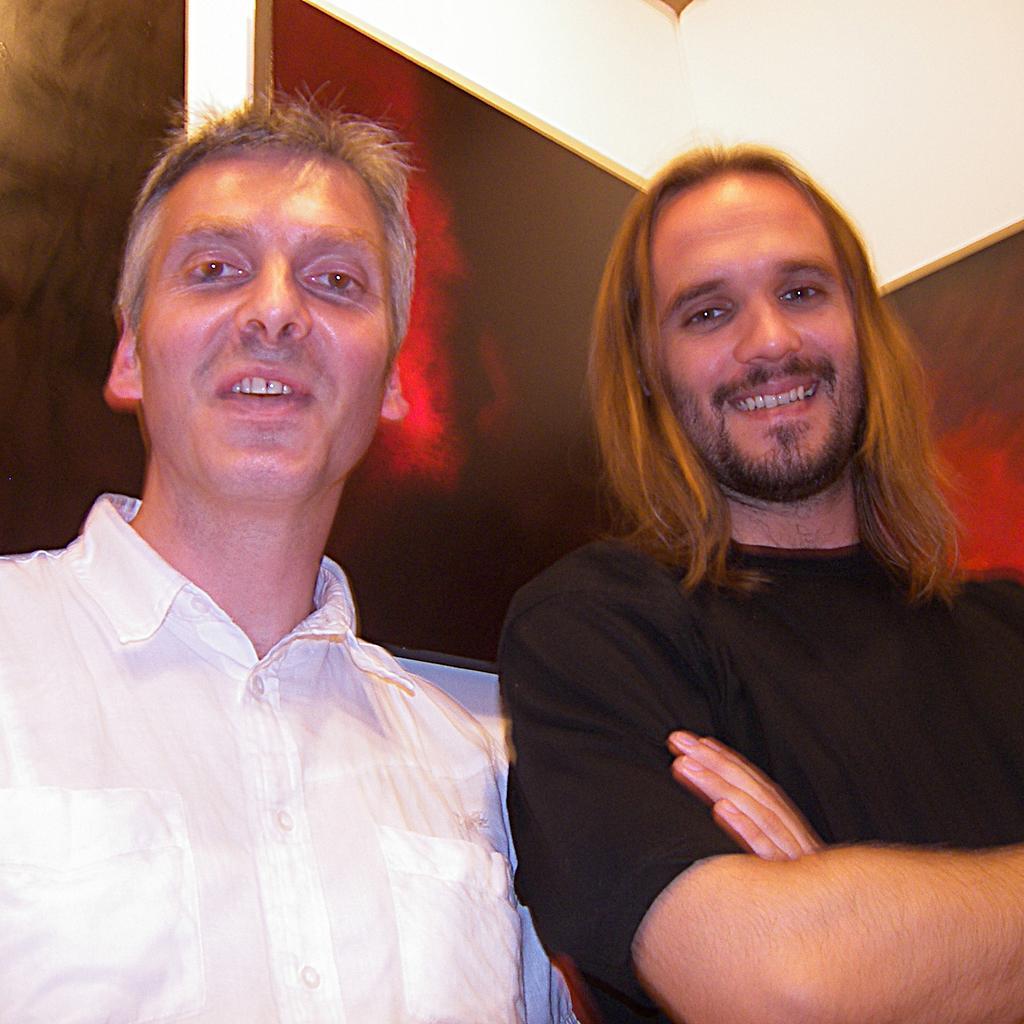Could you give a brief overview of what you see in this image? In the left side a man is there, he wore a white color shirt. In the right side there is another man holding his hands, he wore a black color t-shirt, he is smiling. 